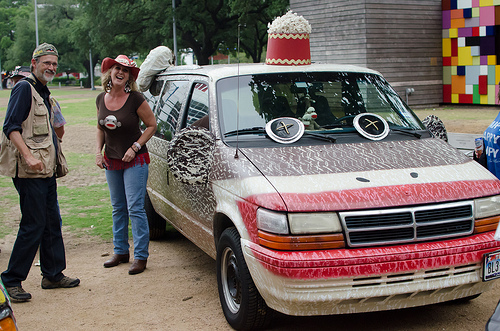<image>
Is there a woman behind the van? No. The woman is not behind the van. From this viewpoint, the woman appears to be positioned elsewhere in the scene. Is the woman behind the car? No. The woman is not behind the car. From this viewpoint, the woman appears to be positioned elsewhere in the scene. Is the woman in the van? No. The woman is not contained within the van. These objects have a different spatial relationship. 